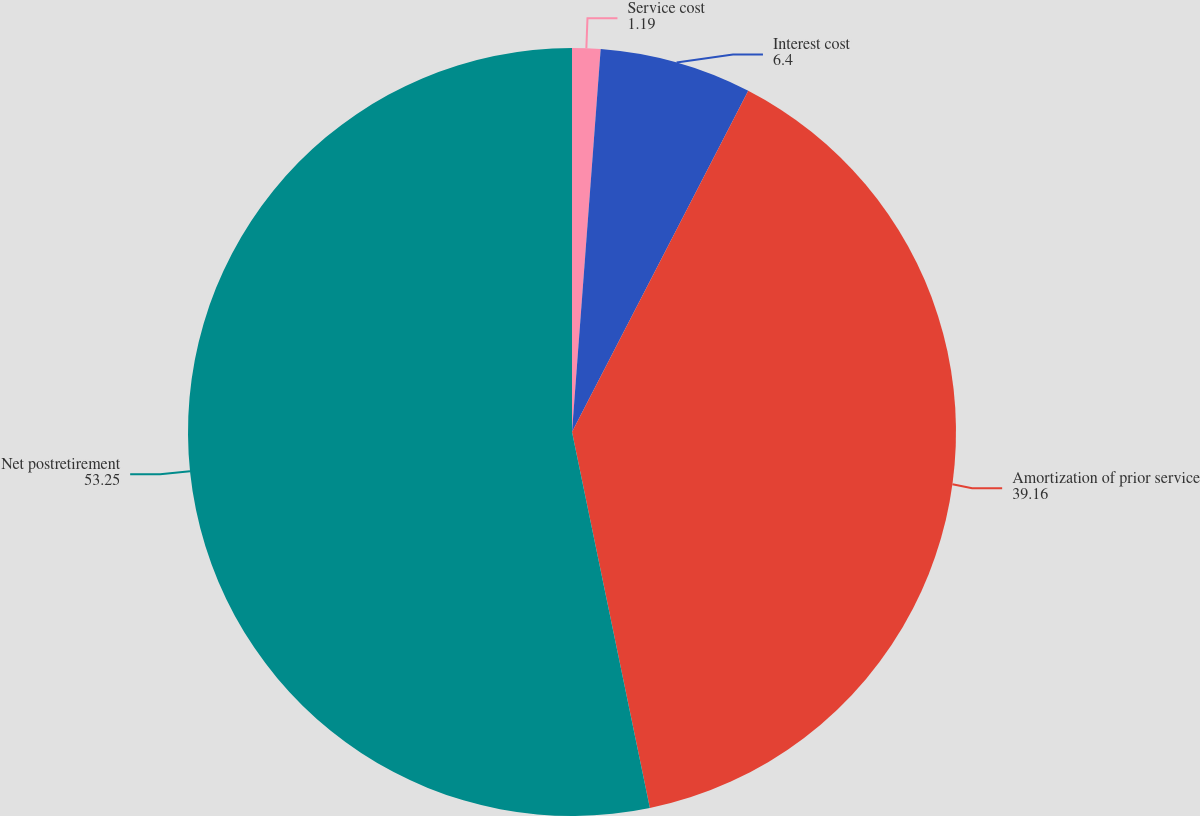Convert chart to OTSL. <chart><loc_0><loc_0><loc_500><loc_500><pie_chart><fcel>Service cost<fcel>Interest cost<fcel>Amortization of prior service<fcel>Net postretirement<nl><fcel>1.19%<fcel>6.4%<fcel>39.16%<fcel>53.25%<nl></chart> 